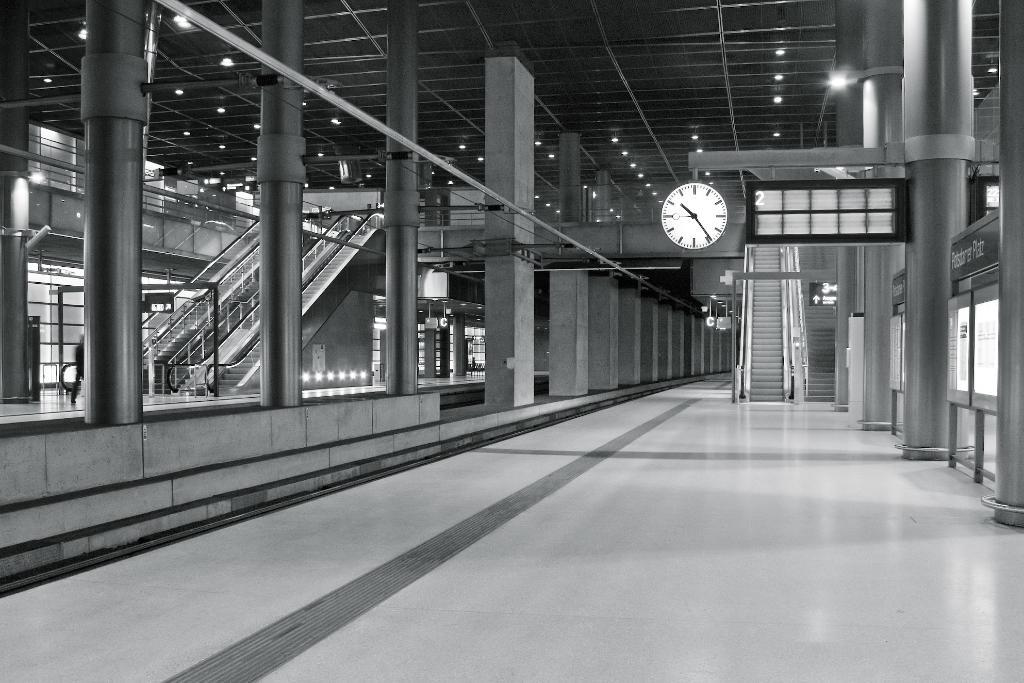What type of location is depicted in the image? The image is an inside picture of a building. What can be seen on the ceiling of the building? Lights are attached to the ceiling. What architectural features are present in the image? There are pillars in the image. What time-keeping device is present in the image? A clock is present in the image. What mode of transportation is visible in the image? Escalators are visible in the image. What type of signage is present in the image? There is a board in the image. Are there any people present in the image? Yes, a person is present in the image. What type of chess pieces can be seen on the board in the image? There is no chess board or pieces present in the image. How many pigs are visible in the image? There are no pigs present in the image. 